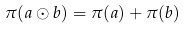<formula> <loc_0><loc_0><loc_500><loc_500>\pi ( a \odot b ) = \pi ( a ) + \pi ( b )</formula> 